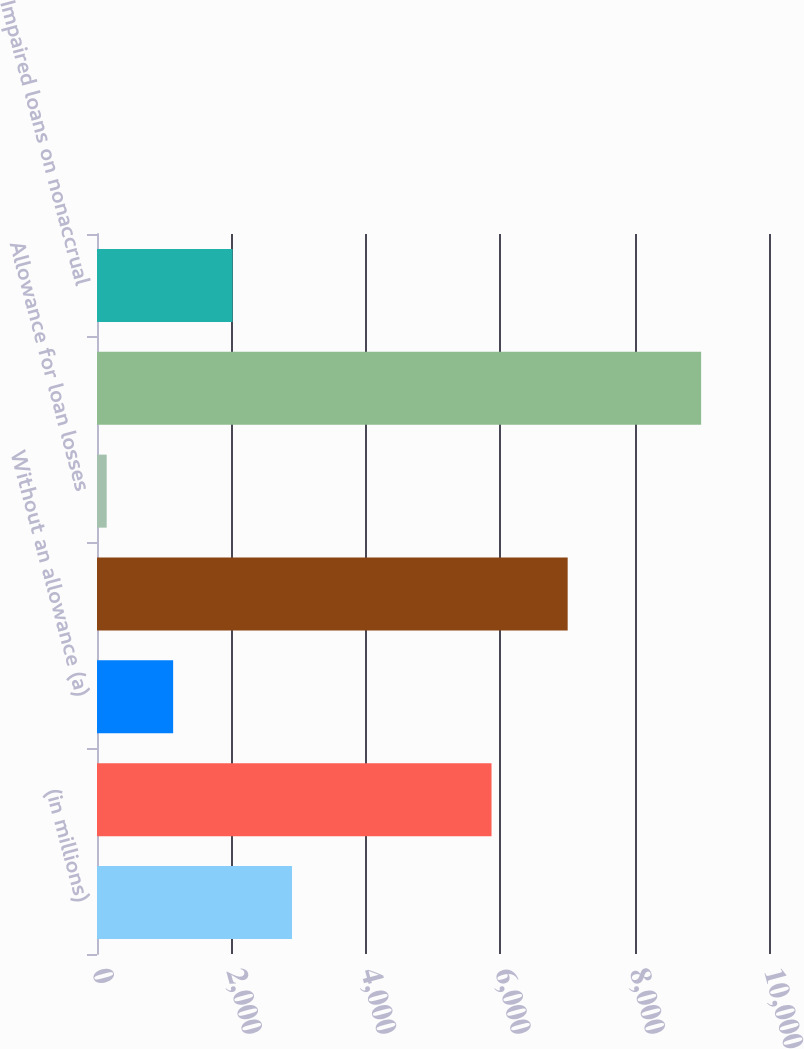<chart> <loc_0><loc_0><loc_500><loc_500><bar_chart><fcel>(in millions)<fcel>With an allowance<fcel>Without an allowance (a)<fcel>Total impaired loans (b)<fcel>Allowance for loan losses<fcel>Unpaid principal balance of<fcel>Impaired loans on nonaccrual<nl><fcel>2902.2<fcel>5871<fcel>1133<fcel>7004<fcel>144<fcel>8990<fcel>2017.6<nl></chart> 